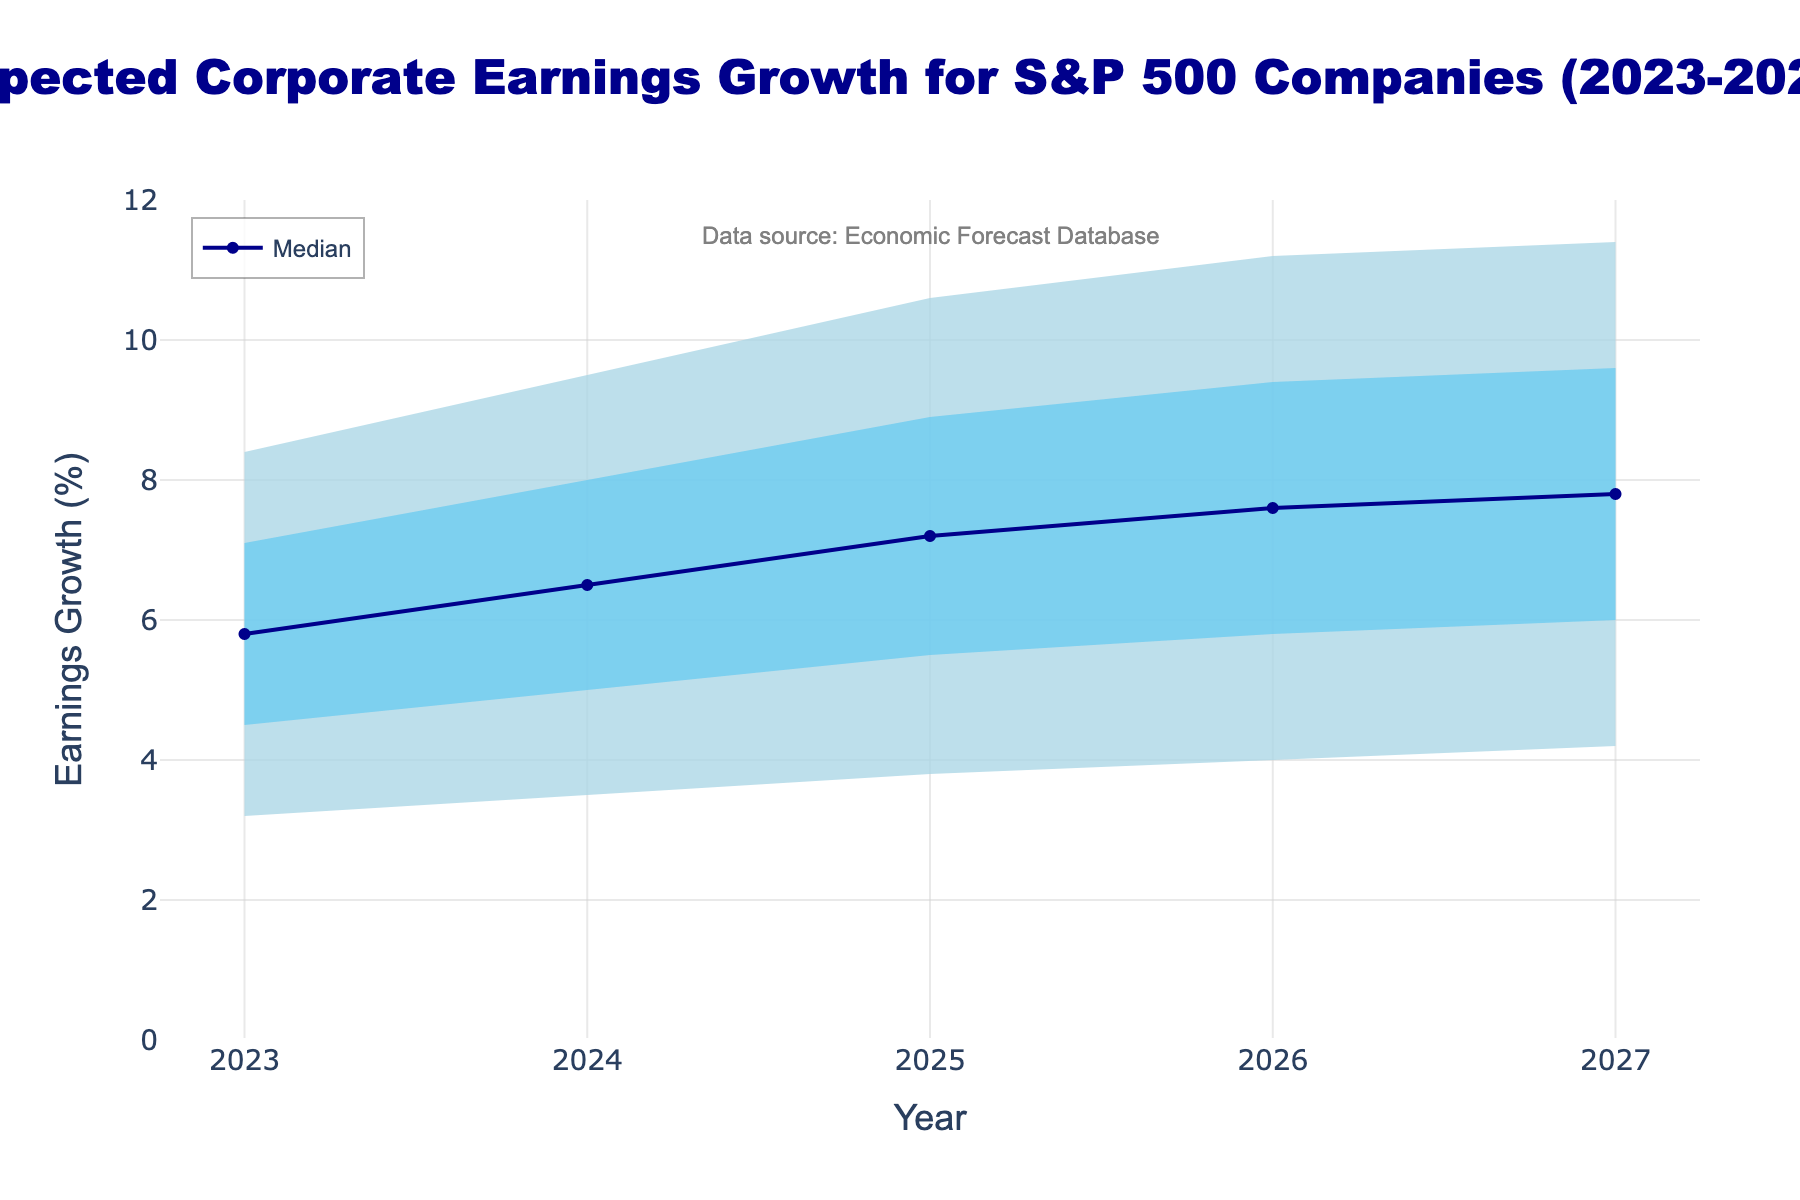What is the title of the figure? The title of the figure is usually displayed at the top and formatted prominently. In this case, it states the main focus of the visualization: Expected Corporate Earnings Growth for S&P 500 Companies (2023-2027).
Answer: Expected Corporate Earnings Growth for S&P 500 Companies (2023-2027) What is the median expected earnings growth for the year 2026? To find the median expected earnings growth, we need to look at the value corresponding to the P50 percentile for the year 2026 in the plot.
Answer: 7.6% Which year has the highest median expected earnings growth? To identify the year with the highest median growth, we compare the values of the P50 percentile across all the years shown in the figure. The year with the highest value is selected.
Answer: 2027 How does the median expected earnings growth change from 2023 to 2024? To understand the change in median expected earnings growth between two years, we need to subtract the median value of 2023 from that of 2024. This involves comparing the P50 percentile values of both years.
Answer: It increases by 0.7% (6.5% - 5.8%) What is the range of expected earnings growth for the year 2025? The range of expected earnings growth can be found by calculating the difference between the 90th percentile (P90) and the 10th percentile (P10) for the year 2025.
Answer: 6.8% (10.6% - 3.8%) Which color represents the range between the 75th and 90th percentiles? Each color band in the fan chart represents a specific range of percentiles. According to the provided code, colors are defined sequentially with 'rgba(0, 191, 255, 0.2)' representing the 75th to 90th percentiles.
Answer: Light blue with low opacity How much did the 10th percentile of expected earnings growth change from 2023 to 2027? To determine the change in the 10th percentile value, subtract the 10th percentile value of 2023 from that of 2027.
Answer: It increased by 1.0% (4.2% - 3.2%) Is the median expected earnings growth ever equal to or greater than 8.0%? To answer this, we need to examine the P50 values for all years and check if any of them are equal to or exceed 8.0%.
Answer: No How does the uncertainty of expected earnings growth change over the years? To assess this, we examine the spread between the 10th and 90th percentiles (width of the fan) for each year. Wider spreads indicate greater uncertainty. Check if the width increases or decreases over the years.
Answer: Uncertainty increases What's the difference between the 75th percentile expected earnings growth in 2024 and 2026? To determine the difference, subtract the 75th percentile value of the earlier year (2024) from the 75th percentile value of the later year (2026).
Answer: 1.4% (9.4% - 8.0%) 